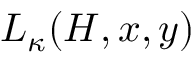Convert formula to latex. <formula><loc_0><loc_0><loc_500><loc_500>L _ { \kappa } ( H , x , y )</formula> 